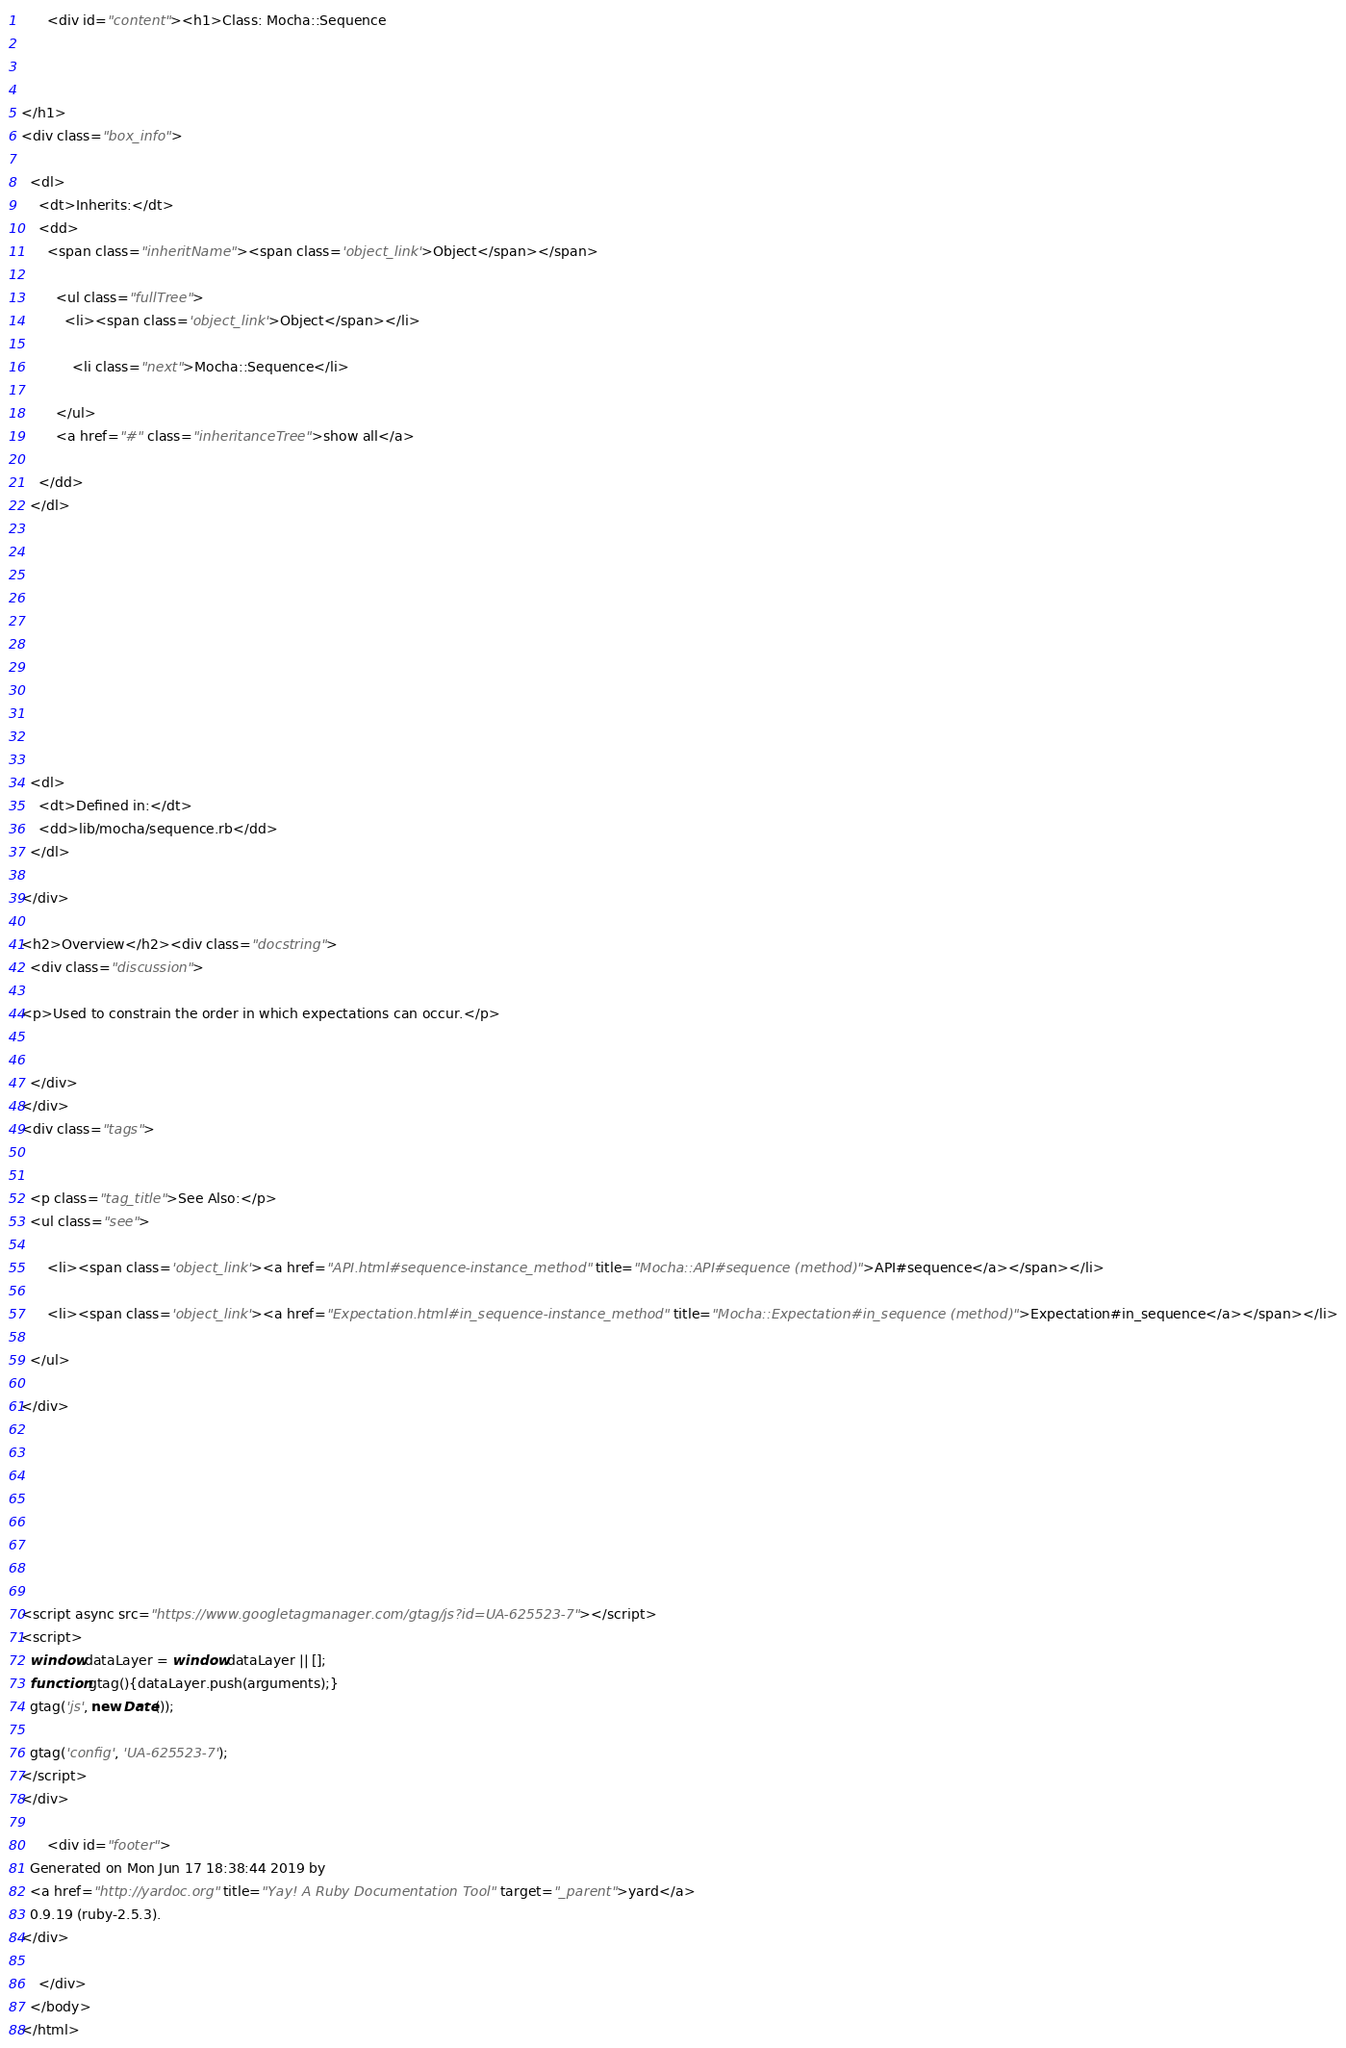<code> <loc_0><loc_0><loc_500><loc_500><_HTML_>
      <div id="content"><h1>Class: Mocha::Sequence
  
  
  
</h1>
<div class="box_info">
  
  <dl>
    <dt>Inherits:</dt>
    <dd>
      <span class="inheritName"><span class='object_link'>Object</span></span>
      
        <ul class="fullTree">
          <li><span class='object_link'>Object</span></li>
          
            <li class="next">Mocha::Sequence</li>
          
        </ul>
        <a href="#" class="inheritanceTree">show all</a>
      
    </dd>
  </dl>
  

  
  
  
  
  

  

  
  <dl>
    <dt>Defined in:</dt>
    <dd>lib/mocha/sequence.rb</dd>
  </dl>
  
</div>

<h2>Overview</h2><div class="docstring">
  <div class="discussion">
    
<p>Used to constrain the order in which expectations can occur.</p>


  </div>
</div>
<div class="tags">
  

  <p class="tag_title">See Also:</p>
  <ul class="see">
    
      <li><span class='object_link'><a href="API.html#sequence-instance_method" title="Mocha::API#sequence (method)">API#sequence</a></span></li>
    
      <li><span class='object_link'><a href="Expectation.html#in_sequence-instance_method" title="Mocha::Expectation#in_sequence (method)">Expectation#in_sequence</a></span></li>
    
  </ul>

</div>








<script async src="https://www.googletagmanager.com/gtag/js?id=UA-625523-7"></script>
<script>
  window.dataLayer = window.dataLayer || [];
  function gtag(){dataLayer.push(arguments);}
  gtag('js', new Date());

  gtag('config', 'UA-625523-7');
</script>
</div>

      <div id="footer">
  Generated on Mon Jun 17 18:38:44 2019 by
  <a href="http://yardoc.org" title="Yay! A Ruby Documentation Tool" target="_parent">yard</a>
  0.9.19 (ruby-2.5.3).
</div>

    </div>
  </body>
</html></code> 